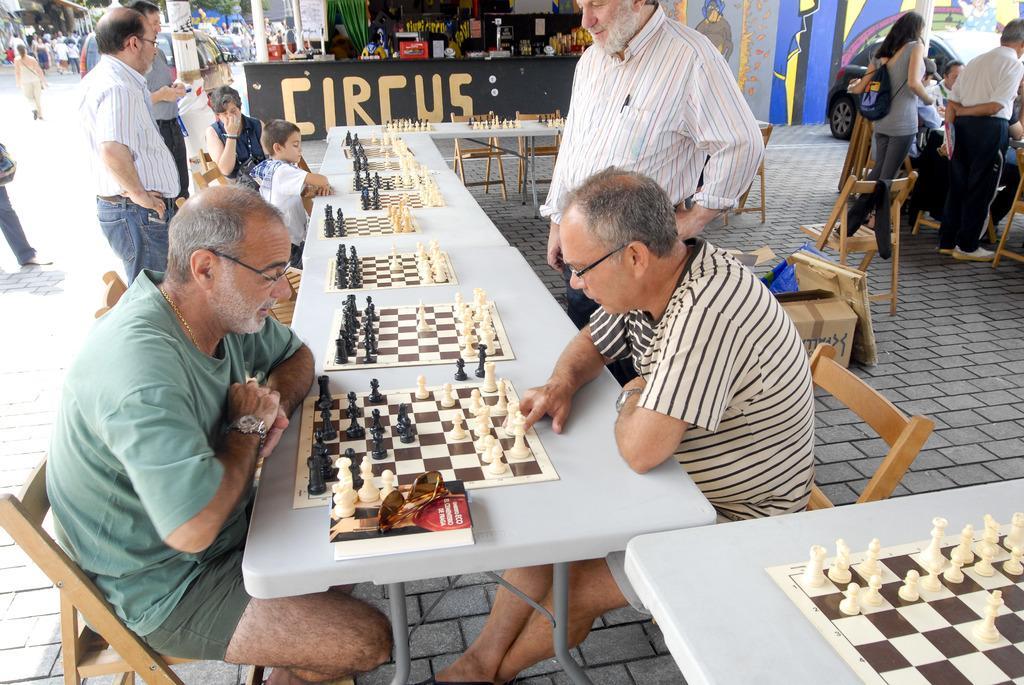Could you give a brief overview of what you see in this image? In this image, there are some persons wearing clothes and sitting on chairs in front of the table. This table contains chess boards, book and sunglasses. There are two persons standing on the top right of the image. There are another two persons standing in the top right of the image. There is a person standing at top of the image. There is a stall at the top of the image. 